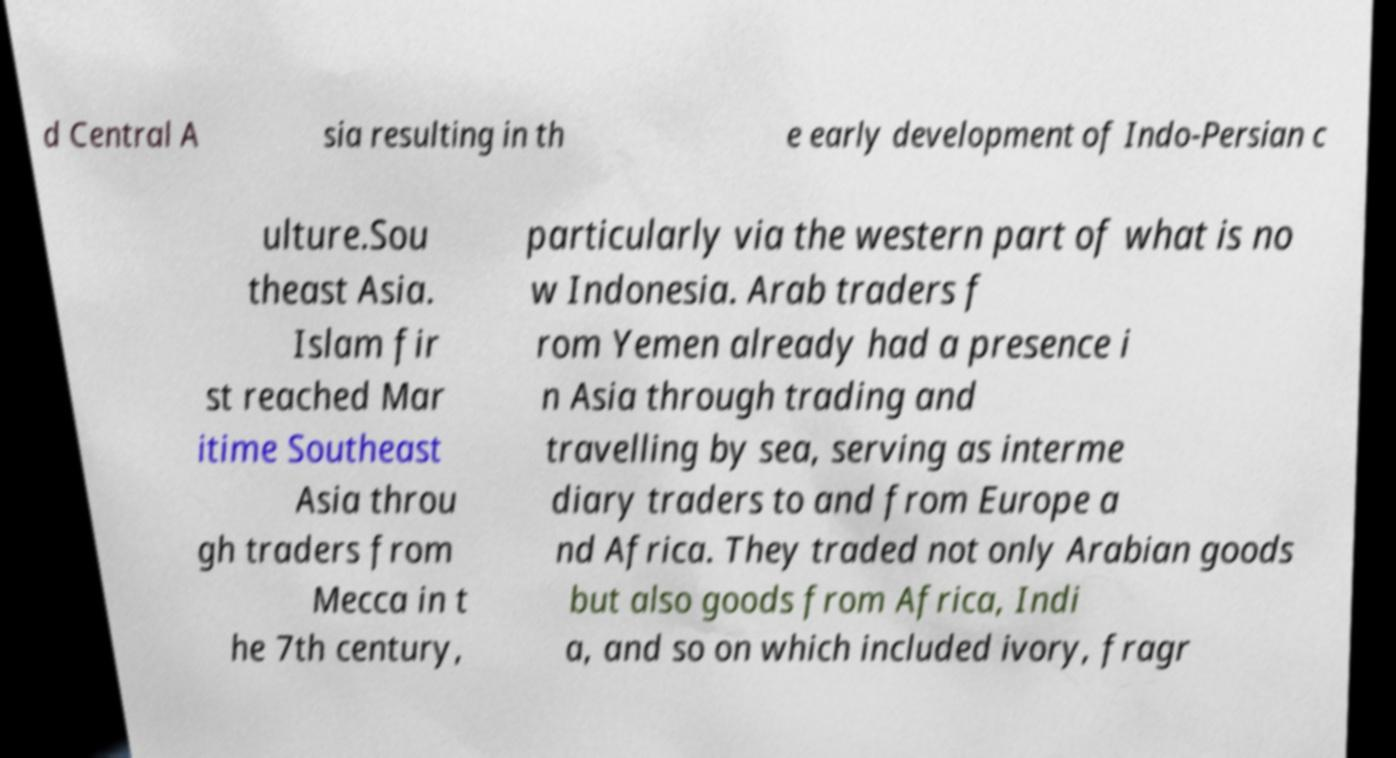Can you read and provide the text displayed in the image?This photo seems to have some interesting text. Can you extract and type it out for me? d Central A sia resulting in th e early development of Indo-Persian c ulture.Sou theast Asia. Islam fir st reached Mar itime Southeast Asia throu gh traders from Mecca in t he 7th century, particularly via the western part of what is no w Indonesia. Arab traders f rom Yemen already had a presence i n Asia through trading and travelling by sea, serving as interme diary traders to and from Europe a nd Africa. They traded not only Arabian goods but also goods from Africa, Indi a, and so on which included ivory, fragr 